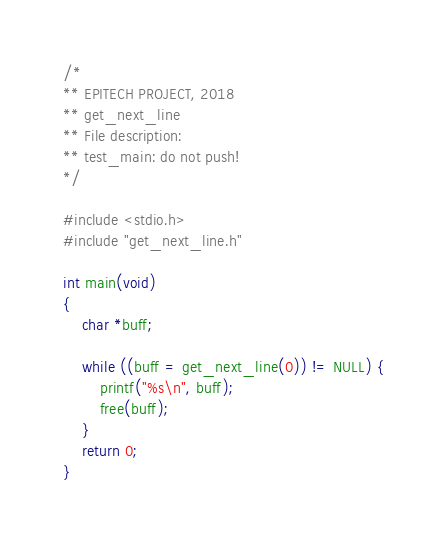Convert code to text. <code><loc_0><loc_0><loc_500><loc_500><_C_>/*
** EPITECH PROJECT, 2018
** get_next_line
** File description:
** test_main: do not push!
*/

#include <stdio.h>
#include "get_next_line.h"

int main(void)
{
	char *buff;

	while ((buff = get_next_line(0)) != NULL) {
		printf("%s\n", buff);
		free(buff);
	}
	return 0;
}
</code> 